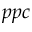Convert formula to latex. <formula><loc_0><loc_0><loc_500><loc_500>p p c</formula> 